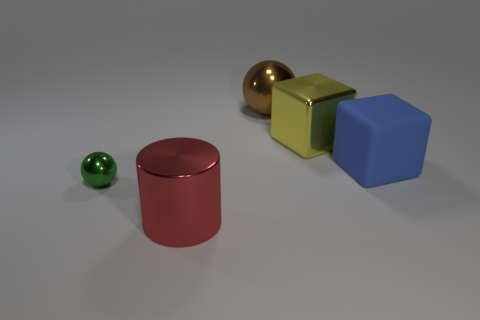There is a thing in front of the small green metal object; are there any blue objects that are in front of it?
Your answer should be very brief. No. Is the number of big red things that are to the right of the yellow shiny object less than the number of small green metallic balls?
Your answer should be compact. Yes. Does the sphere that is behind the green object have the same material as the large red object?
Ensure brevity in your answer.  Yes. There is a big cube that is made of the same material as the small green ball; what is its color?
Your answer should be compact. Yellow. Is the number of matte things that are behind the shiny block less than the number of large blue matte blocks to the left of the tiny object?
Give a very brief answer. No. Do the metal thing that is in front of the small green thing and the ball behind the small sphere have the same color?
Offer a very short reply. No. Is there a tiny green ball made of the same material as the blue object?
Provide a short and direct response. No. There is a metallic object that is on the right side of the large brown object that is right of the tiny green metal ball; how big is it?
Your answer should be compact. Large. Is the number of large cyan blocks greater than the number of metallic objects?
Your answer should be very brief. No. There is a ball behind the blue object; is it the same size as the large red cylinder?
Your response must be concise. Yes. 